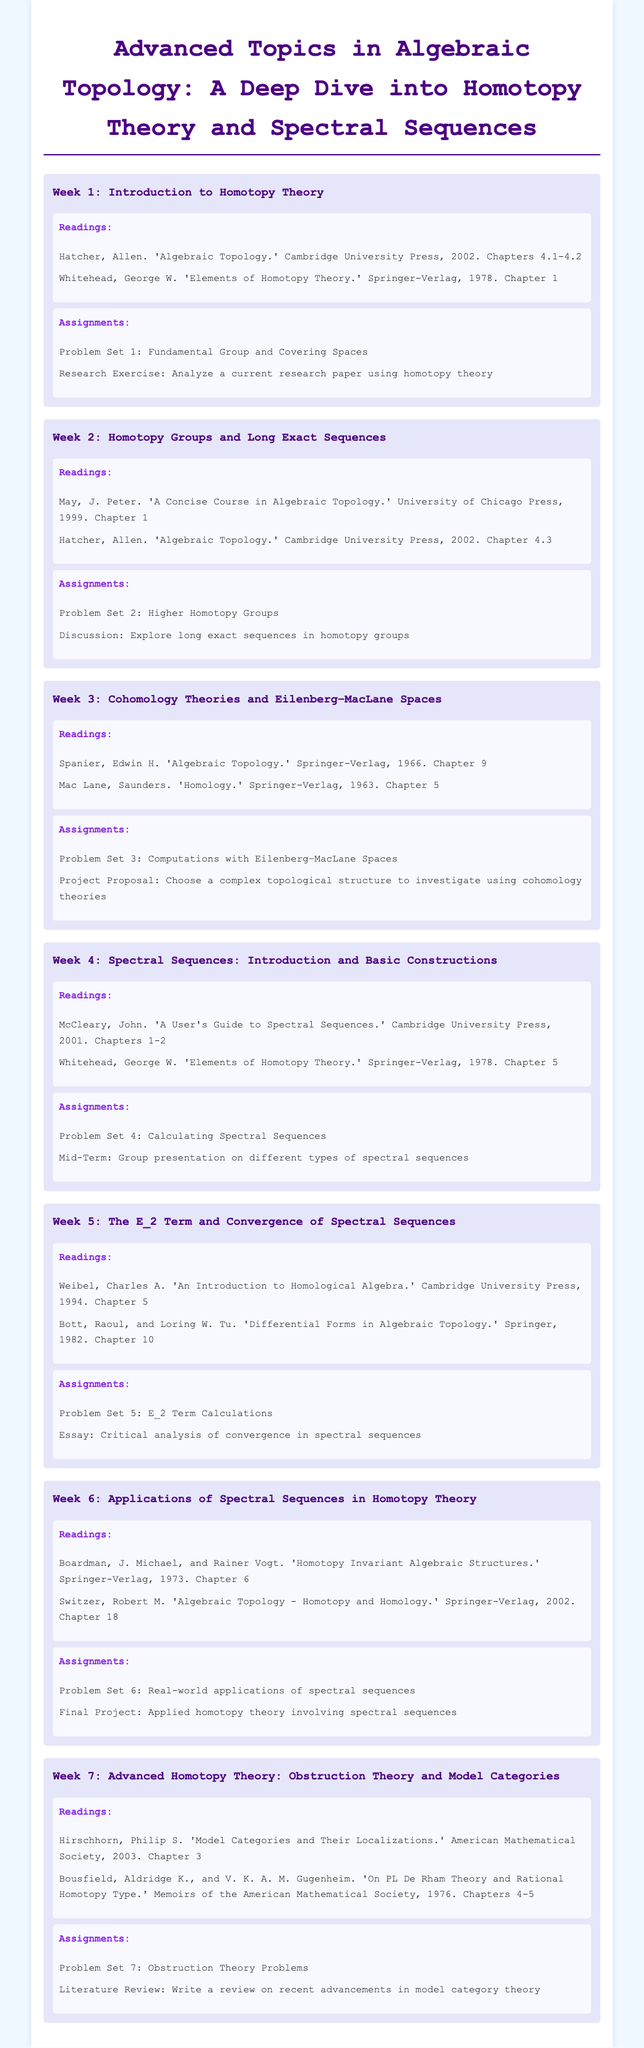What is the title of the course? The title of the course is found at the top of the document.
Answer: Advanced Topics in Algebraic Topology: A Deep Dive into Homotopy Theory and Spectral Sequences Who is the author of the reading material for Week 1? The author is mentioned in the readings section for Week 1.
Answer: Hatcher, Allen How many problem sets are there in total? The document lists problem sets for each week, counting them provides the total.
Answer: 7 What is the topic of Week 3? The topic is specified at the beginning of the week section.
Answer: Cohomology Theories and Eilenberg–MacLane Spaces Which chapter of McCleary's book is assigned for Week 4 readings? The document specifies the chapters in the readings section for Week 4.
Answer: Chapters 1-2 What is the main focus of the final project in Week 6? The final project is outlined in the Week 6 assignments section.
Answer: Applied homotopy theory involving spectral sequences How many weeks are covered in this syllabus? The number of weeks is determined by counting the sections labeled as "Week".
Answer: 7 What significant theory is introduced in Week 7? The significant theory is indicated at the start of Week 7.
Answer: Obstruction Theory and Model Categories 